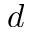Convert formula to latex. <formula><loc_0><loc_0><loc_500><loc_500>d</formula> 